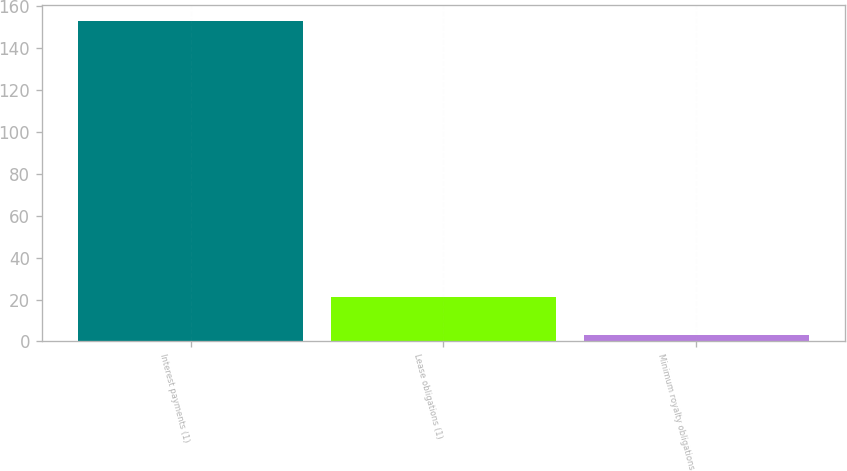Convert chart to OTSL. <chart><loc_0><loc_0><loc_500><loc_500><bar_chart><fcel>Interest payments (1)<fcel>Lease obligations (1)<fcel>Minimum royalty obligations<nl><fcel>153<fcel>21<fcel>3<nl></chart> 